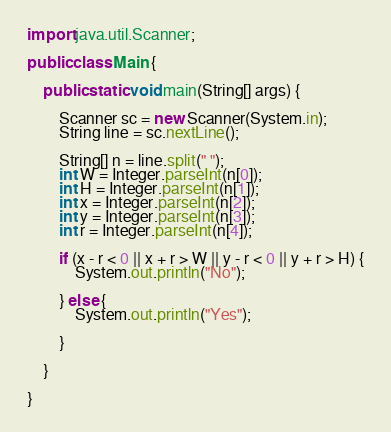<code> <loc_0><loc_0><loc_500><loc_500><_Java_>import java.util.Scanner;

public class Main {

	public static void main(String[] args) {

		Scanner sc = new Scanner(System.in);
		String line = sc.nextLine();

		String[] n = line.split(" ");
		int W = Integer.parseInt(n[0]);
		int H = Integer.parseInt(n[1]);
		int x = Integer.parseInt(n[2]);
		int y = Integer.parseInt(n[3]);
		int r = Integer.parseInt(n[4]);

		if (x - r < 0 || x + r > W || y - r < 0 || y + r > H) {
			System.out.println("No");

		} else {
			System.out.println("Yes");

		}

	}

}

</code> 